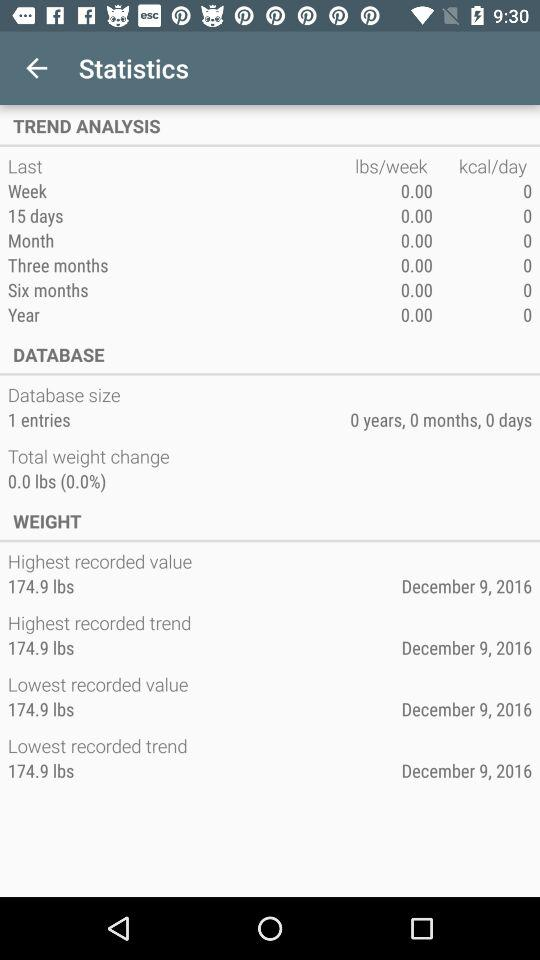What is the lowest recorded value? The lowest recorded value is 174.9 lbs. 